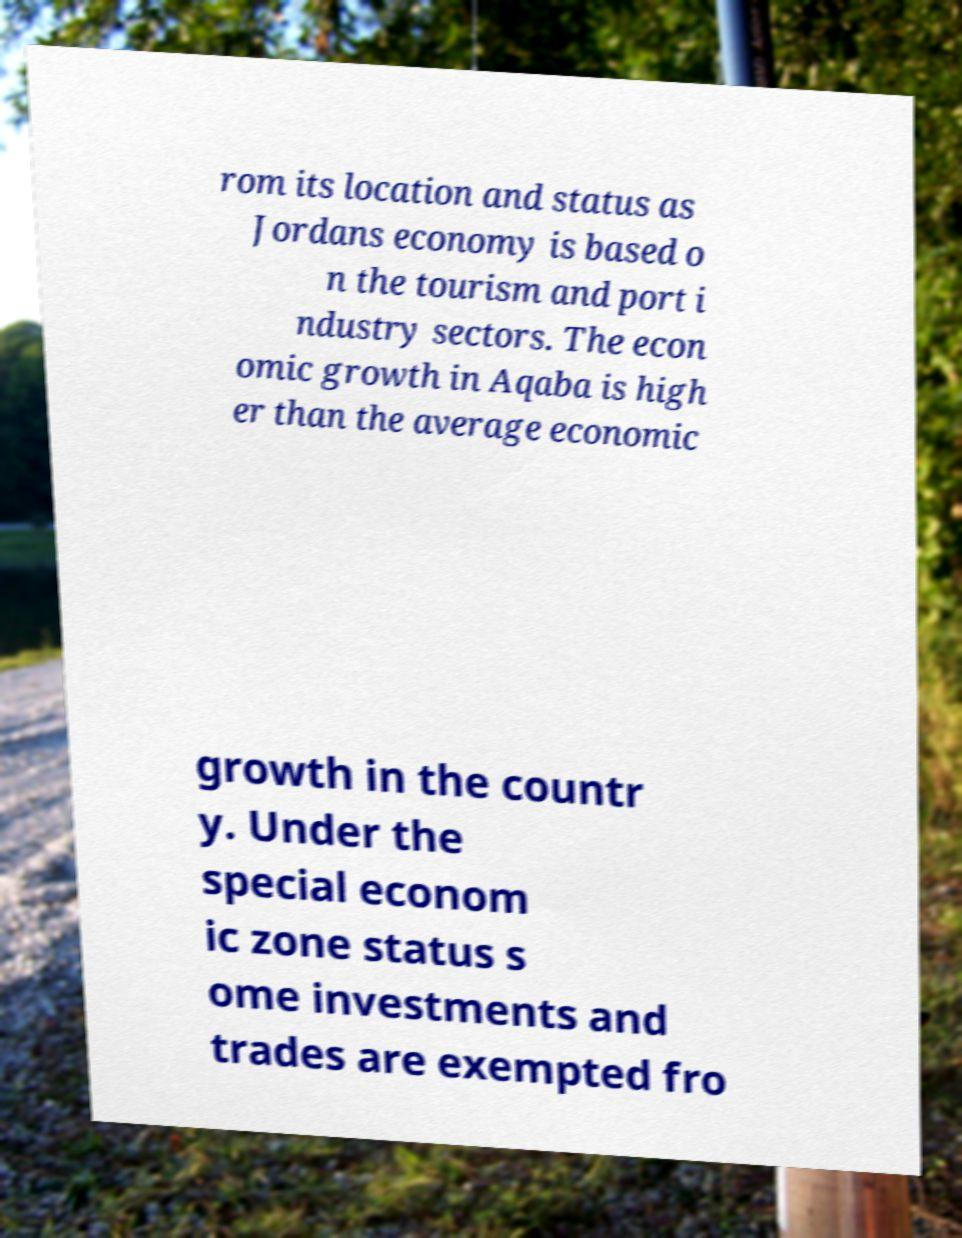I need the written content from this picture converted into text. Can you do that? rom its location and status as Jordans economy is based o n the tourism and port i ndustry sectors. The econ omic growth in Aqaba is high er than the average economic growth in the countr y. Under the special econom ic zone status s ome investments and trades are exempted fro 